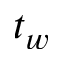<formula> <loc_0><loc_0><loc_500><loc_500>t _ { w }</formula> 